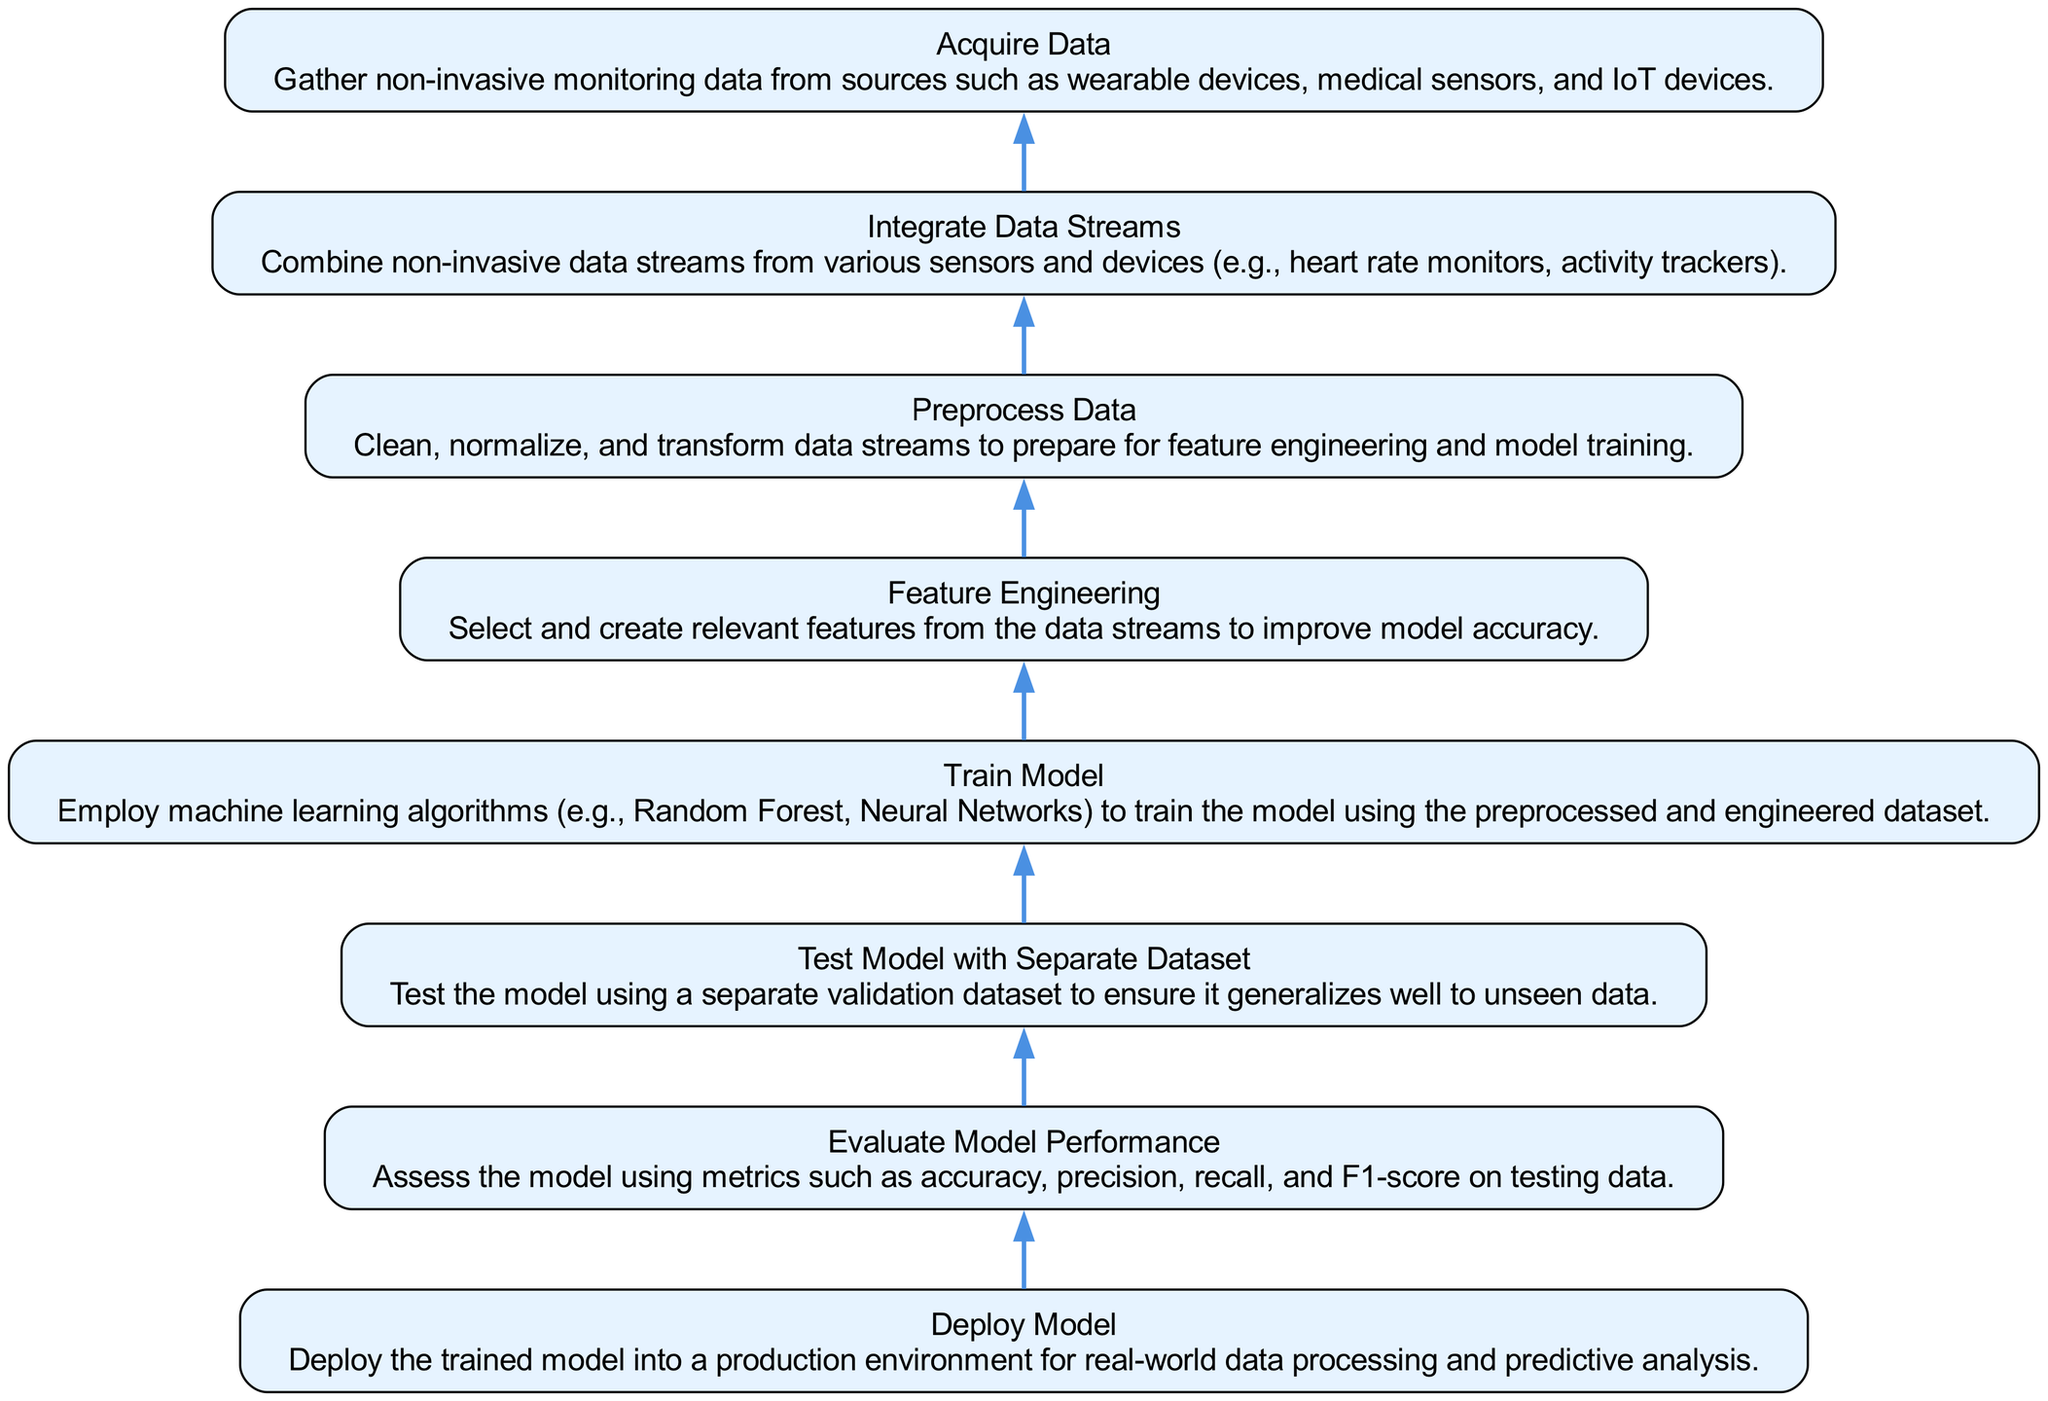What is the first step in the diagram? The first step in the diagram is "Acquire Data", which is located at the bottom of the flow chart and indicates the initial action required to gather non-invasive monitoring data.
Answer: Acquire Data How many nodes are present in the diagram? The diagram contains eight nodes, representing different steps in the process of training a machine learning model using non-invasive data streams.
Answer: Eight What is the last action to be performed in the flow? The last action in the flow is "Deploy Model", which appears at the top of the diagram and is the final step after the model has been trained and evaluated.
Answer: Deploy Model Which step follows "Preprocess Data"? The step that follows "Preprocess Data" is "Feature Engineering", indicating that after data preprocessing, relevant features should be selected and created.
Answer: Feature Engineering What evaluation metrics are highlighted during model performance assessment? The evaluation metrics mentioned for assessing model performance include accuracy, precision, recall, and F1-score, which are essential for determining how well the model performs on testing data.
Answer: Accuracy, precision, recall, and F1-score If the model does not generalize well, which step should be revisited? If the model does not generalize well, the step to revisit is "Test Model with Separate Dataset", as this step ensures the model's ability to handle unseen data effectively.
Answer: Test Model with Separate Dataset What is the relationship between "Integrate Data Streams" and "Acquire Data"? "Integrate Data Streams" follows directly after "Acquire Data" in the flow, demonstrating that once data is gathered from various sources, it should be combined to proceed with further processing.
Answer: Integrate Data Streams follows Acquire Data What is the main purpose of the "Train Model" step? The primary purpose of the "Train Model" step is to employ machine learning algorithms on the preprocessed and engineered dataset to create a predictive model.
Answer: Employ machine learning algorithms How are the steps connected in this flow chart? The steps in this flow chart are connected sequentially, indicating a linear process where each step must be completed before moving on to the next one, forming a progression from data acquisition to model deployment.
Answer: Sequentially connected 